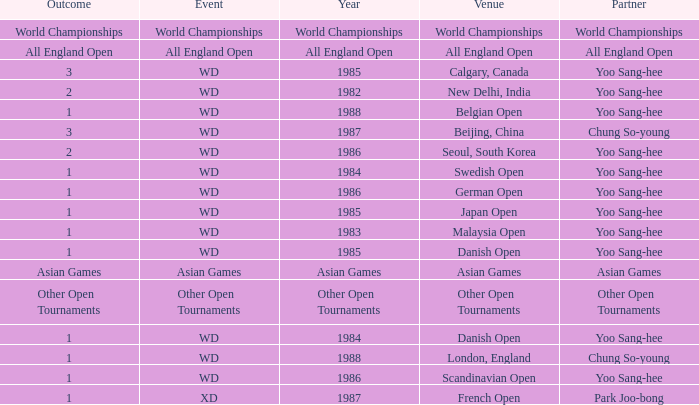What was the Venue in 1986 with an Outcome of 1? Scandinavian Open, German Open. 